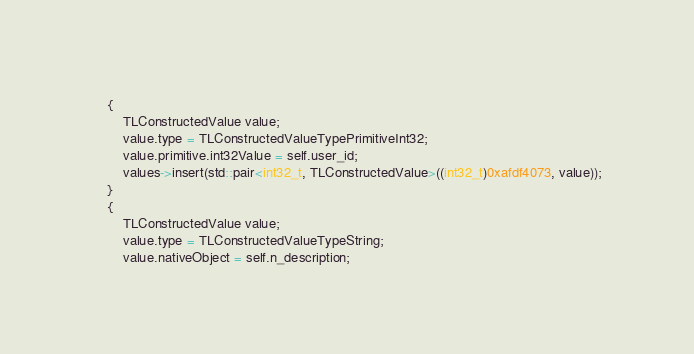Convert code to text. <code><loc_0><loc_0><loc_500><loc_500><_ObjectiveC_>    {
        TLConstructedValue value;
        value.type = TLConstructedValueTypePrimitiveInt32;
        value.primitive.int32Value = self.user_id;
        values->insert(std::pair<int32_t, TLConstructedValue>((int32_t)0xafdf4073, value));
    }
    {
        TLConstructedValue value;
        value.type = TLConstructedValueTypeString;
        value.nativeObject = self.n_description;</code> 